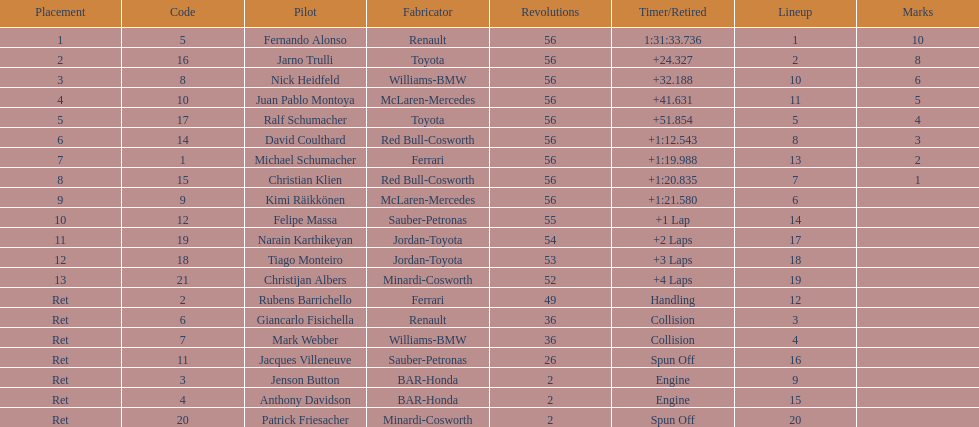What were the total number of laps completed by the 1st position winner? 56. 